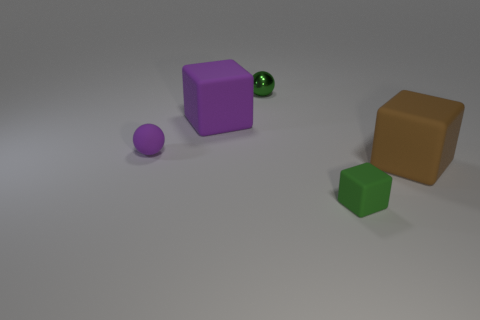Is the number of big brown rubber objects that are behind the small green metal object less than the number of big brown rubber cubes that are on the left side of the large purple rubber thing? The image showcases only one brown cube-like rubber object, which is located on the right side of the frame and not behind any green metal objects or to the left side of the large purple rubber object. Therefore, the question makes assumptions about the positions and quantities of objects that do not apply to this image. To accurately describe this scene: there is one large purple rubber cube, one small purple sphere, one small green cube, one small brown cube, and one small green metallic sphere. None of the brown objects are positioned behind the small green metal object, so it's not possible to compare the stated quantities. 